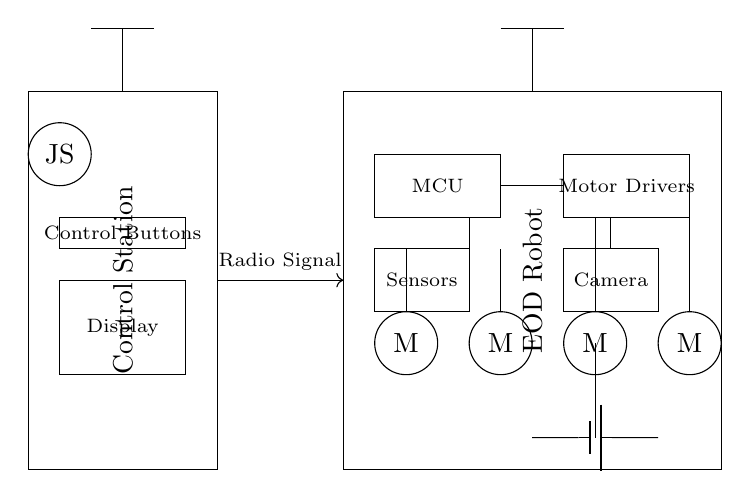What is the main component responsible for controlling the robot's movements? The main component responsible for controlling the robot's movements is the Motor Drivers, which receive commands from the microcontroller to drive the motors.
Answer: Motor Drivers How many motors are depicted in the circuit diagram? The diagram shows four motors, each represented as a circle labeled 'M'.
Answer: Four What type of signal is transmitted from the control station to the EOD robot? The signal transmitted from the control station to the EOD robot is a Radio Signal, as indicated by the directional arrow in the diagram.
Answer: Radio Signal What component provides power to the robot? The component that provides power to the robot is the Battery, shown at the bottom of the robot section in the diagram.
Answer: Battery Which component would be used for navigation assistance in the robot? The component used for navigation assistance is the Camera, as it is illustrated in the robot section and plays a crucial role in visual processing.
Answer: Camera What is the function of the microcontroller in this control system? The microcontroller (MCU) processes the inputs from the control station and sends commands to the motor drivers and sensors for operation, coordinating the entire control system.
Answer: Processing commands What is the purpose of the control buttons in the circuit? The control buttons allow the operator at the control station to send specific commands to the robot, facilitating manual operation and control of the robot's functions.
Answer: Sending commands 